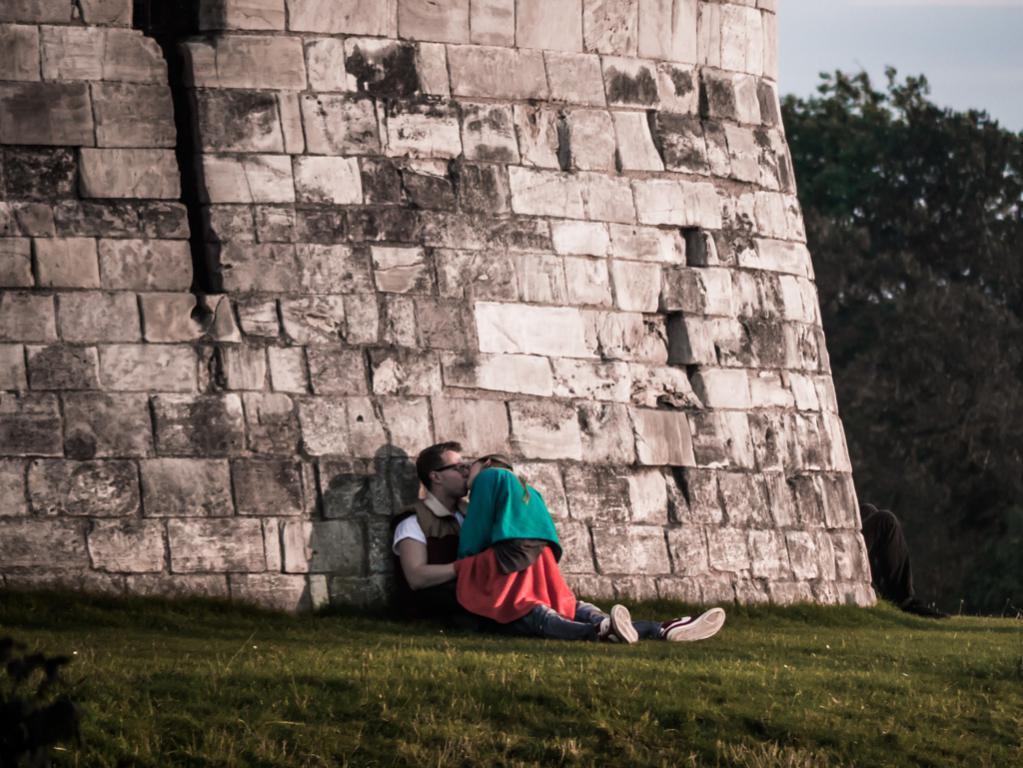Can you describe this image briefly? In this picture we can see two persons are kissing. Here we can see grass. In the background there is a wall, trees, and sky. 